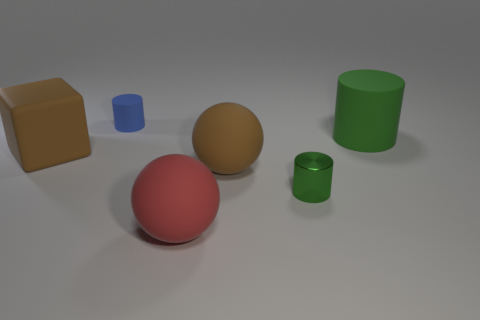Add 2 big cylinders. How many objects exist? 8 Subtract all balls. How many objects are left? 4 Add 5 small blue matte cylinders. How many small blue matte cylinders exist? 6 Subtract 0 gray cylinders. How many objects are left? 6 Subtract all green shiny balls. Subtract all small matte cylinders. How many objects are left? 5 Add 1 big matte spheres. How many big matte spheres are left? 3 